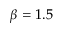Convert formula to latex. <formula><loc_0><loc_0><loc_500><loc_500>\beta = 1 . 5</formula> 